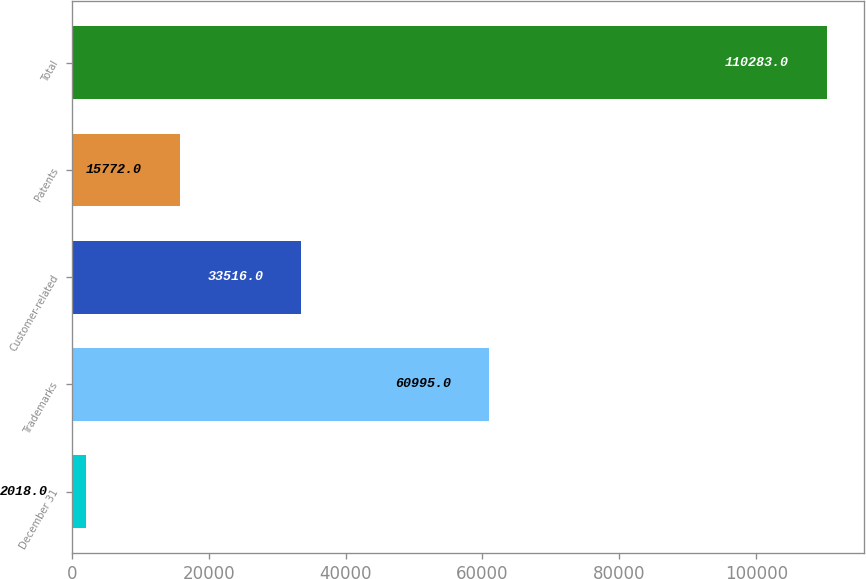<chart> <loc_0><loc_0><loc_500><loc_500><bar_chart><fcel>December 31<fcel>Trademarks<fcel>Customer-related<fcel>Patents<fcel>Total<nl><fcel>2018<fcel>60995<fcel>33516<fcel>15772<fcel>110283<nl></chart> 